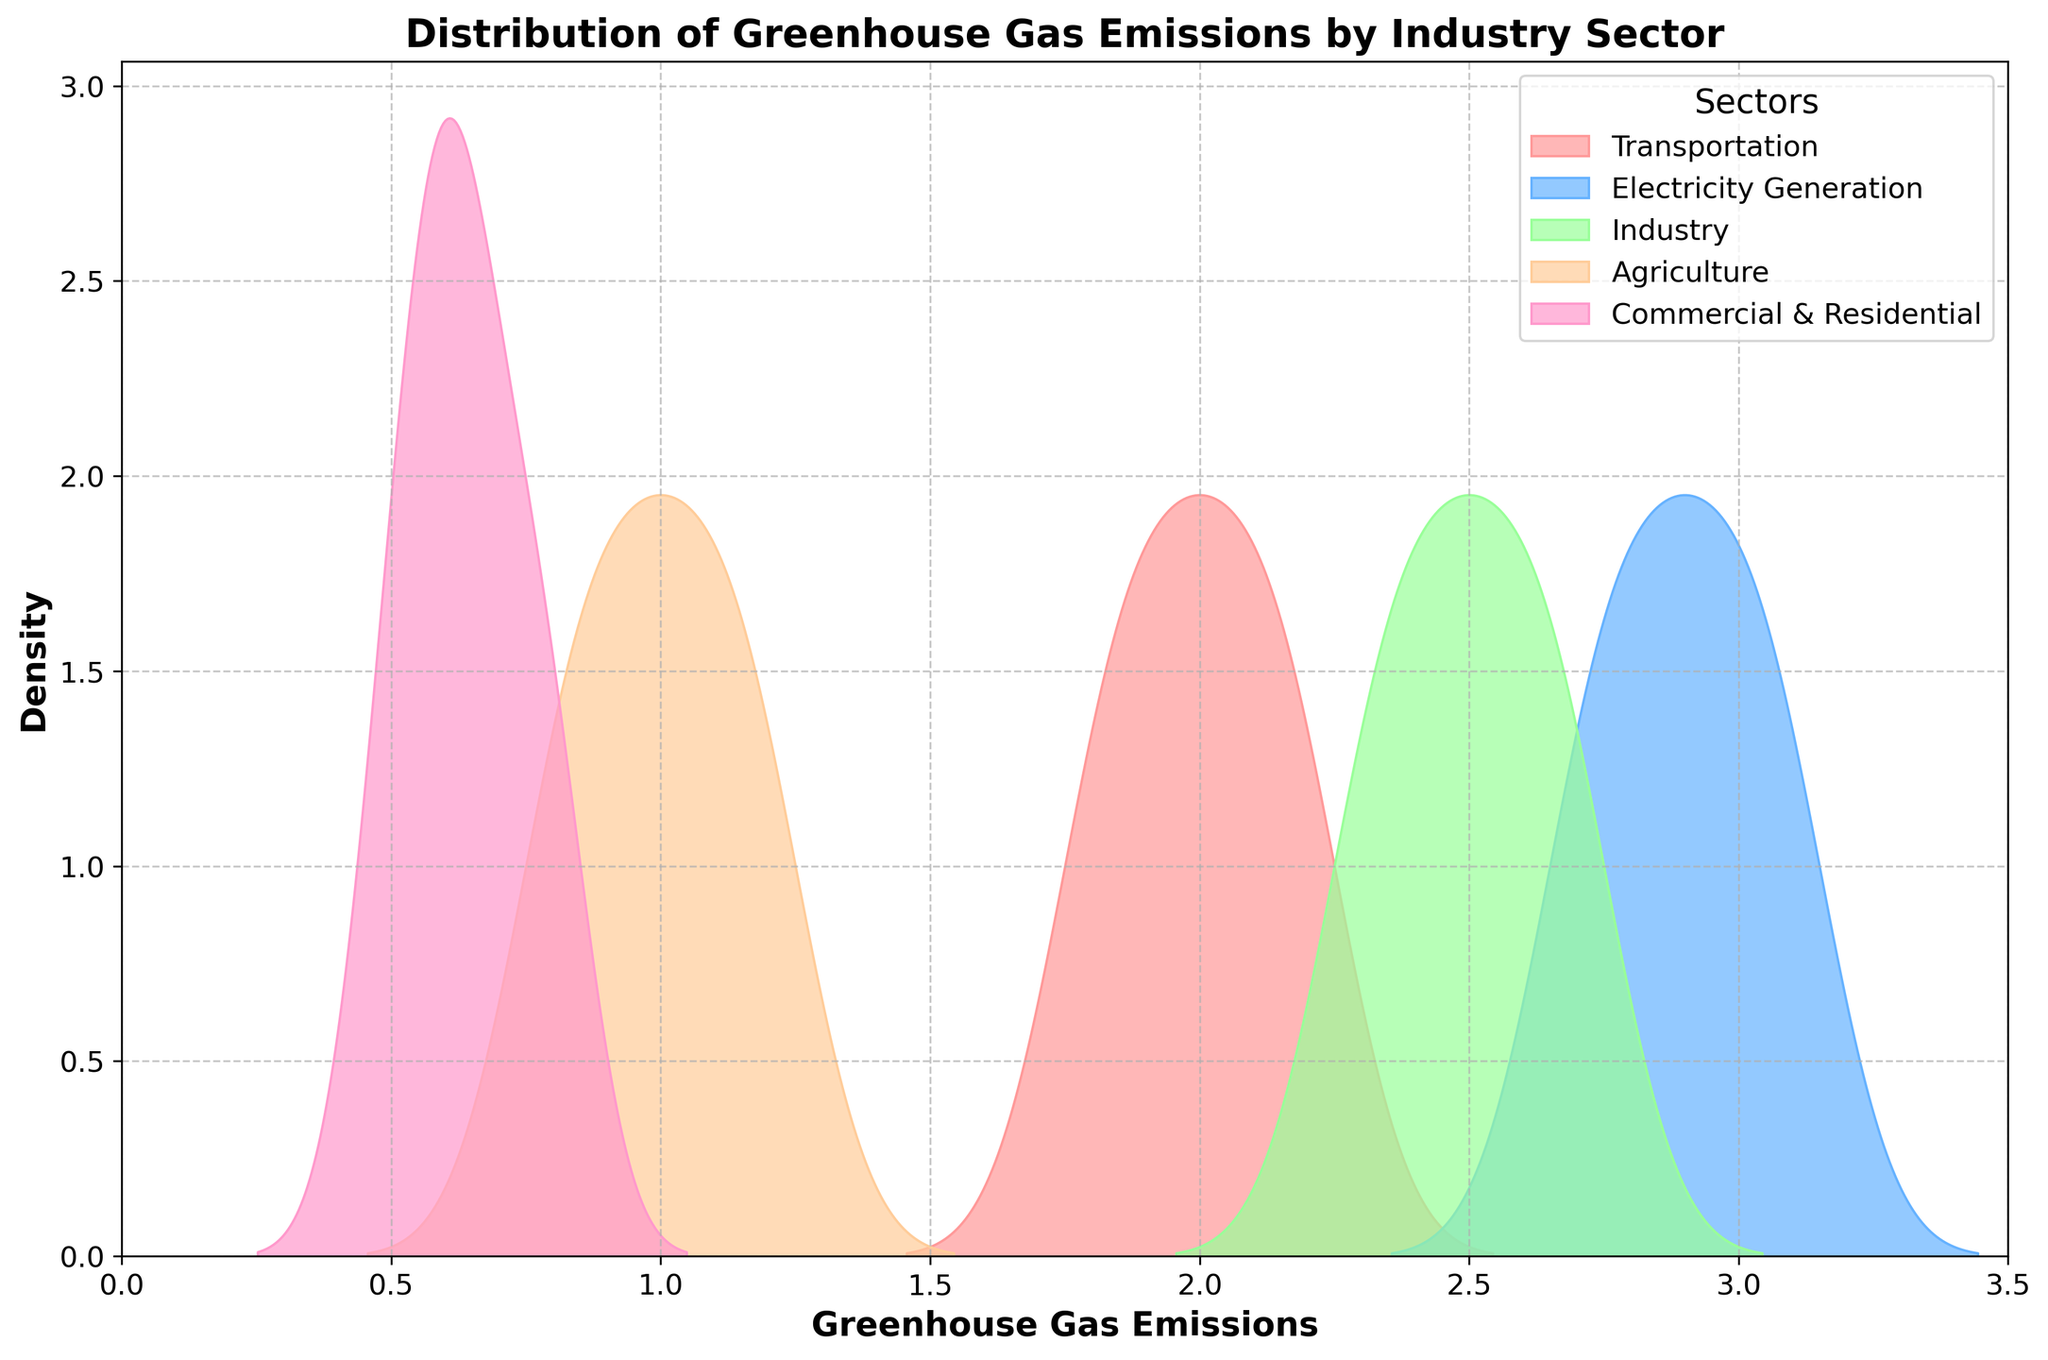What is the title of the figure? The title is typically found at the top of the figure, usually enlarged compared to the rest of the text.
Answer: Distribution of Greenhouse Gas Emissions by Industry Sector What are the labels on the x and y axes? The x-axis label is usually at the bottom of the figure, and the y-axis label is typically on the left side.
Answer: Greenhouse Gas Emissions and Density Which sector has the highest peak density? By observing the figure, the highest peak is the one that reaches the highest point on the y-axis.
Answer: Electricity Generation Which sector has the lowest median emissions? To find the median, look for the central value in the density curve. The sector with the lowest central concentration is identifiable by the curve's position on the x-axis.
Answer: Commercial & Residential How does the distribution of emissions for Transportation compare with Agriculture? Compare the position and spread of the curves for both sectors on the x-axis. Agriculture has a peak shifted toward lower emissions compared to Transportation, which is more centered around its peak.
Answer: Transportation has higher emissions Which sector shows the greatest variation in emissions? Variation is indicated by the spread of the density curve. The sector with the widest curve on the x-axis exhibits the greatest variation.
Answer: Agriculture Between Transportation and Industry, which has higher overall emissions? By examining the peak positions and the spread of the density curves, one can compare which sector's curve overlaps more with higher values on the x-axis.
Answer: Transportation What is the emission range for Electricity Generation? The range of emissions is deduced by observing the starting and ending points of the density curve on the x-axis.
Answer: 2.7 to 3.1 How many sectors have a peak density over 0.5? Count the number of curves that rise above the 0.5 mark on the y-axis.
Answer: Three If you combine the distributions of all sectors, what would be the expected center of the combined density curve? By averaging the peak positions of all the curves, you get a rough estimate of the combined center
Answer: Around 2.0 